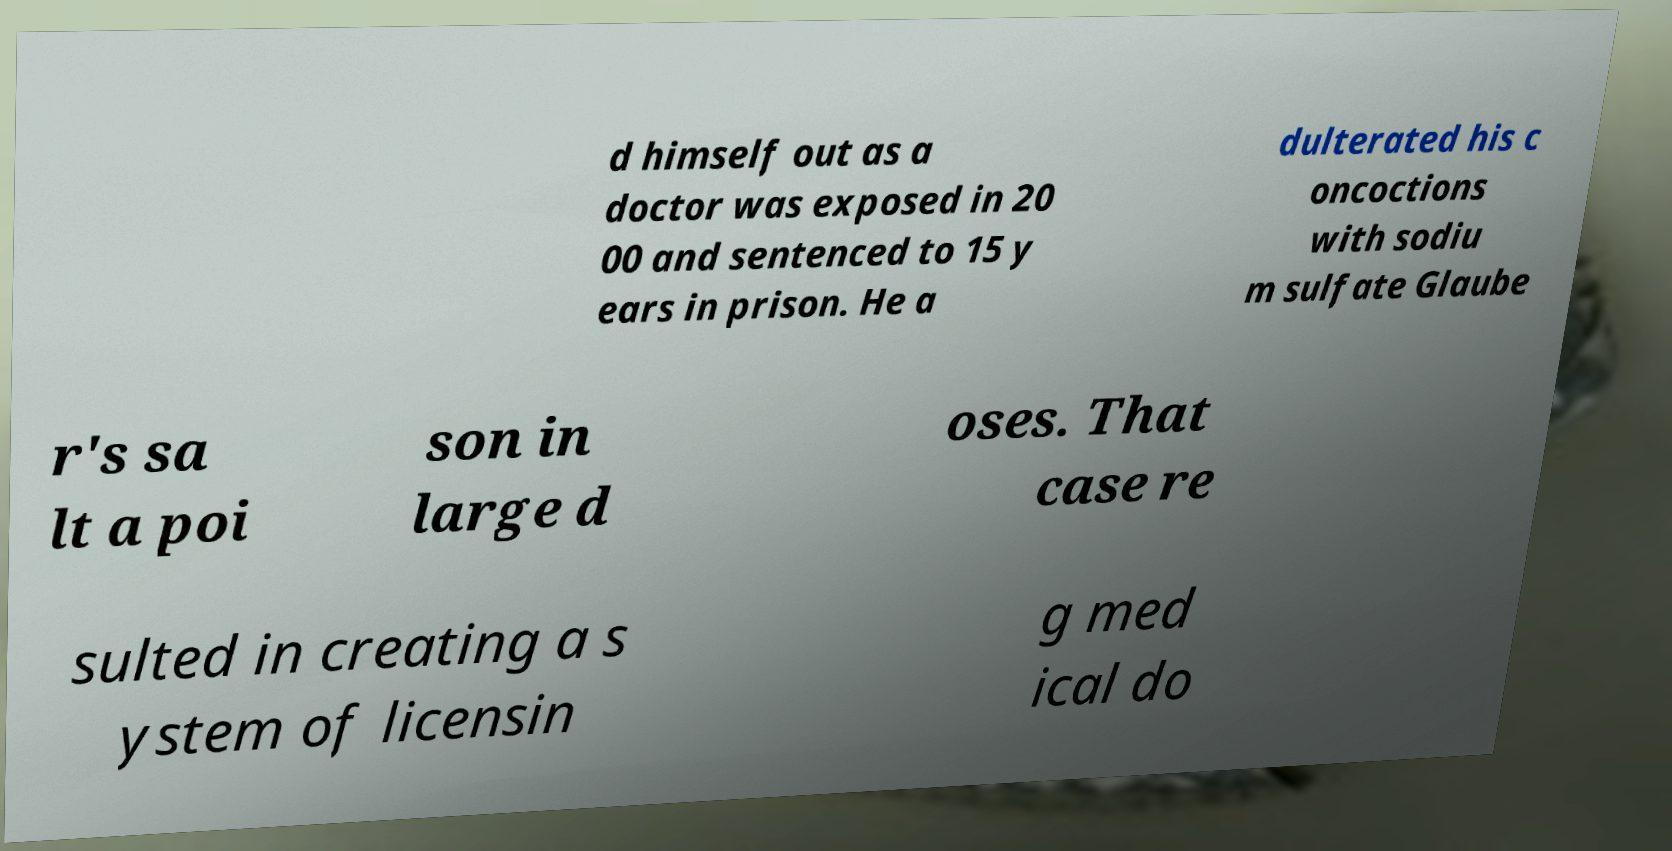What messages or text are displayed in this image? I need them in a readable, typed format. d himself out as a doctor was exposed in 20 00 and sentenced to 15 y ears in prison. He a dulterated his c oncoctions with sodiu m sulfate Glaube r's sa lt a poi son in large d oses. That case re sulted in creating a s ystem of licensin g med ical do 